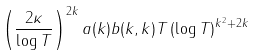Convert formula to latex. <formula><loc_0><loc_0><loc_500><loc_500>\left ( \frac { 2 \kappa } { \log T } \right ) ^ { 2 k } a ( k ) b ( k , k ) T \left ( \log T \right ) ^ { k ^ { 2 } + 2 k }</formula> 